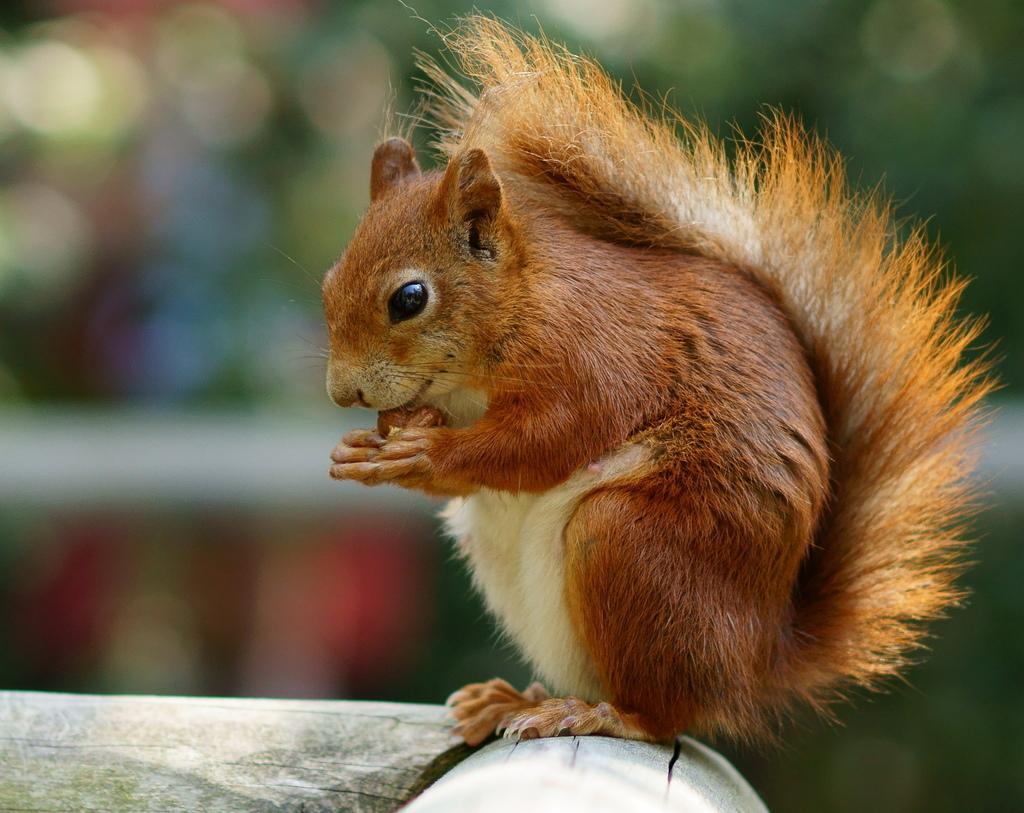Please provide a concise description of this image. In this picture we can see a squirrel and blurry background. 